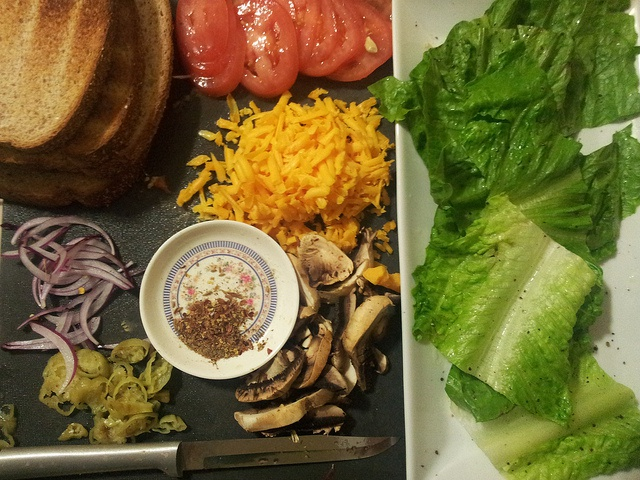Describe the objects in this image and their specific colors. I can see bowl in orange, tan, and beige tones and knife in orange, black, and gray tones in this image. 